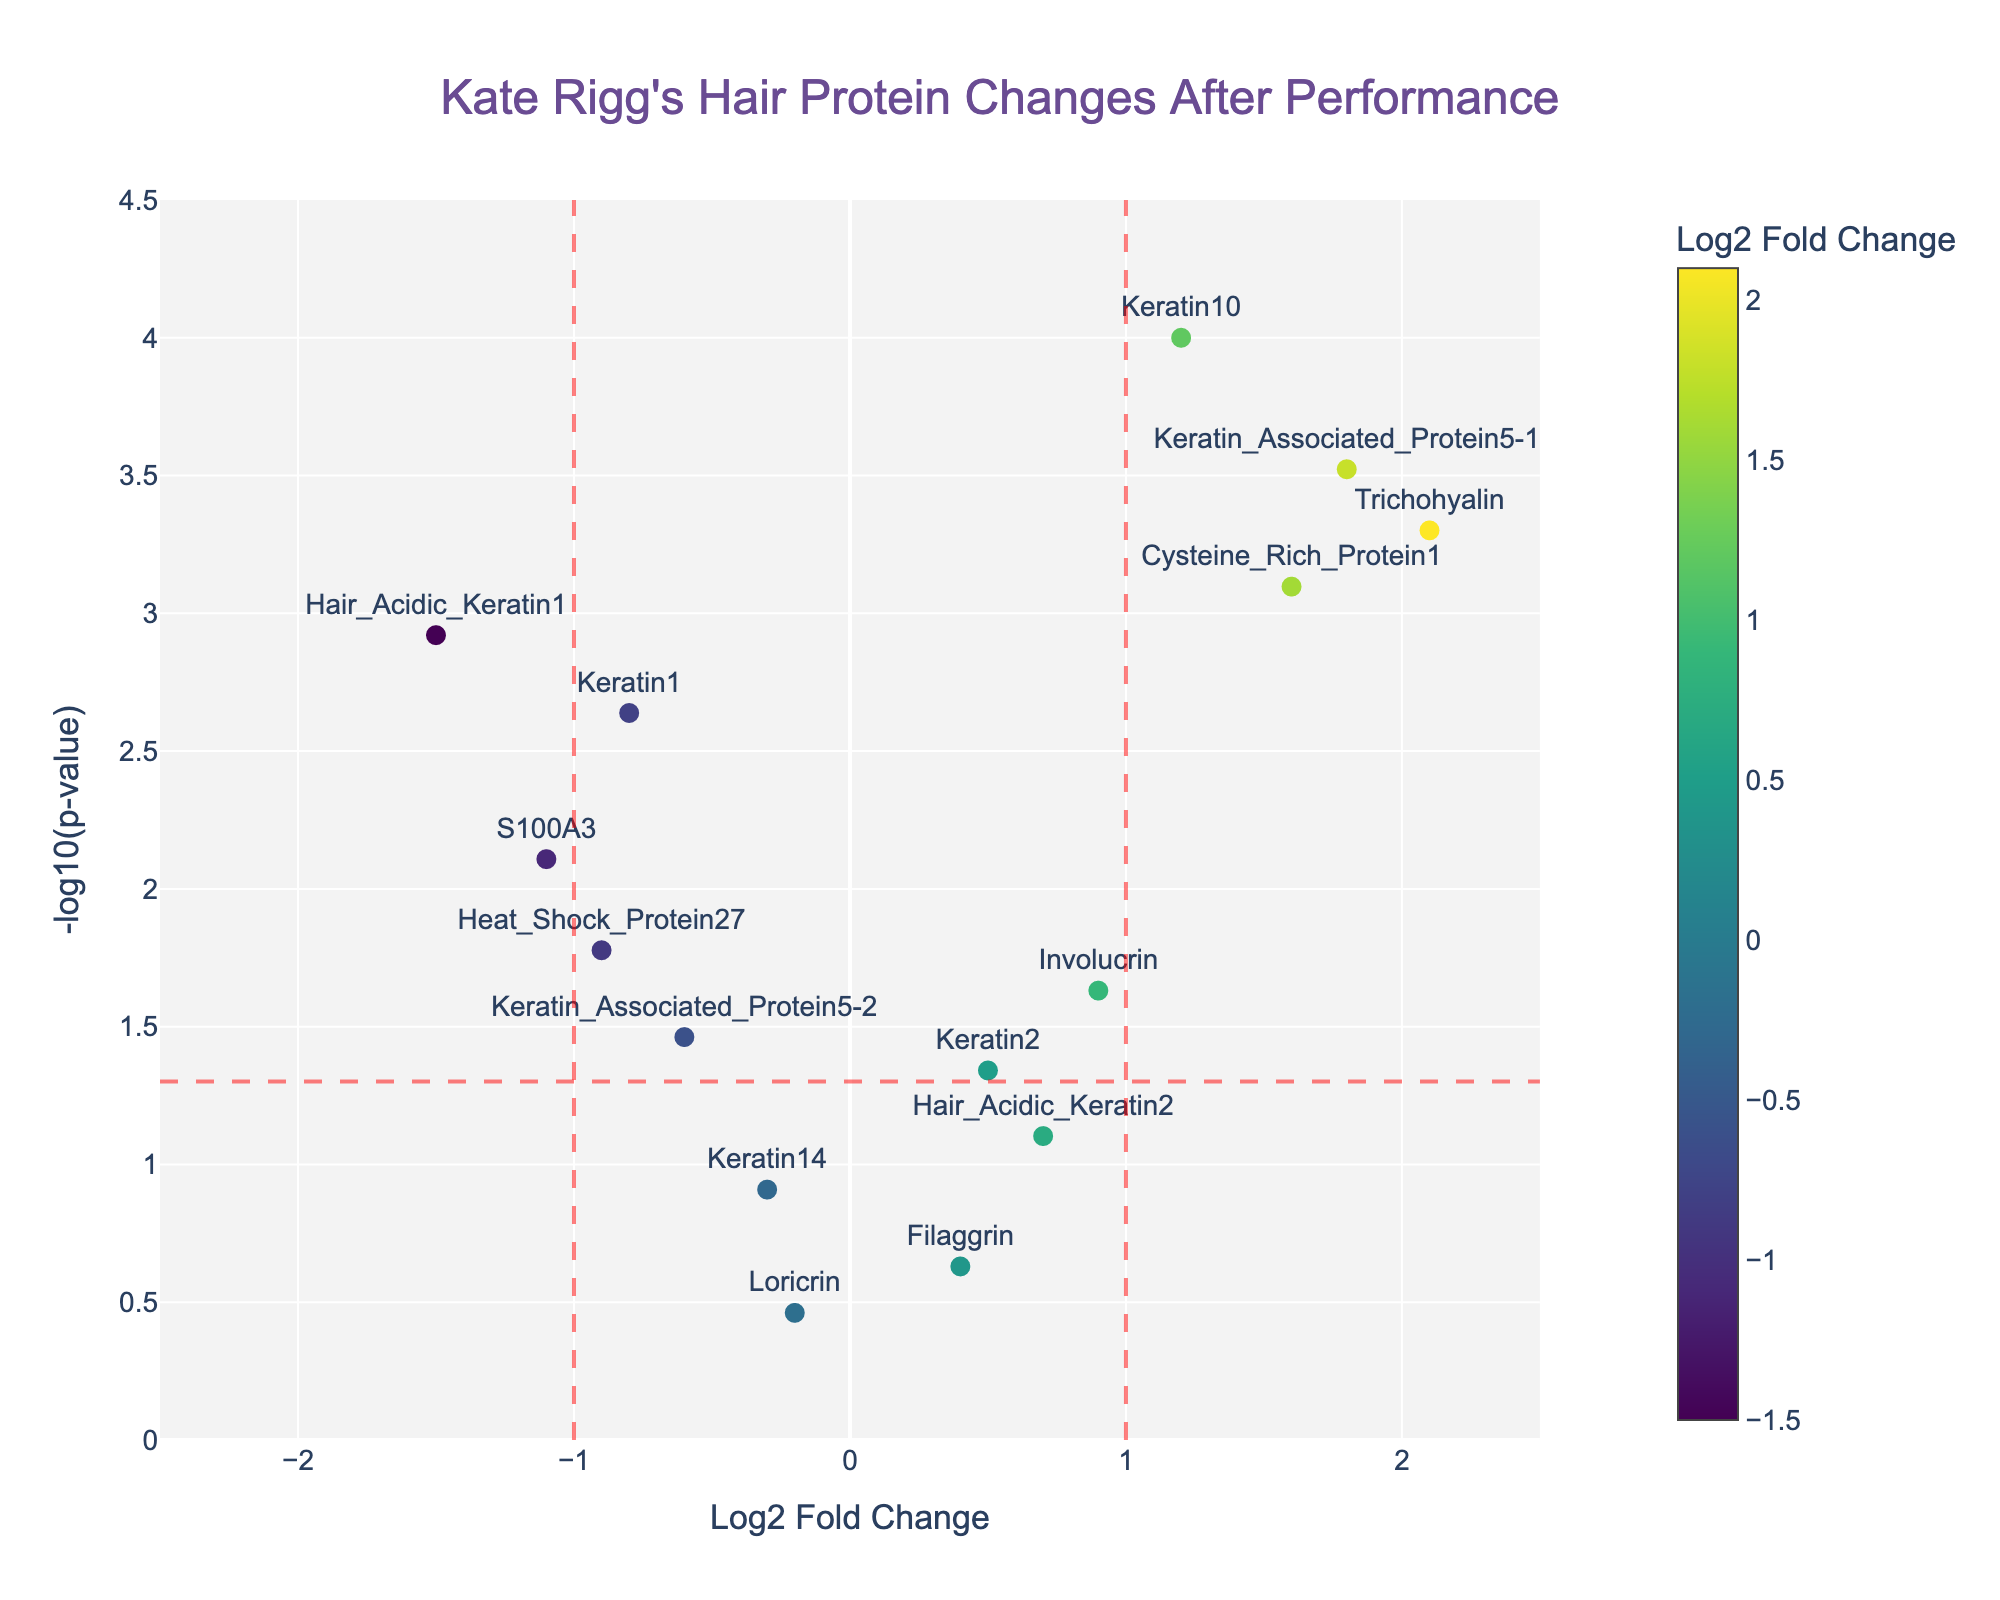What is the title of the plot? The title of the plot is displayed prominently at the top center of the figure and provides an overview of what the plot represents.
Answer: Kate Rigg's Hair Protein Changes After Performance How many proteins have a p-value less than 0.05? Proteins with p-values less than 0.05 are found below the horizontal red dashed line at -log10(p-value) corresponding to 0.05. Count these points.
Answer: 10 Which protein has the highest Log2 Fold Change and what is its p-value? Locate the protein with the highest x-axis value (Log2 Fold Change) and refer to its corresponding p-value from the hover text or the plot.
Answer: Trichohyalin with p-value 0.0005 What are the log2 fold changes for Keratin1 and Keratin14? Find these proteins on the plot and note their x-axis values (Log2 Fold Change).
Answer: -0.8 and -0.3 Which protein shows the most significant change in abundance (in p-value) and indicate its Log2 Fold Change? This is the point with the highest y-axis value (-log10(p-value)). Identify the protein and its corresponding Log2 Fold Change.
Answer: Keratin10 with Log2 Fold Change 1.2 Rank the top three proteins with the highest absolute Log2 Fold Change values. Calculate the absolute values of Log2 Fold Change, then sort and rank them to find the top three.
Answer: Hair_Acidic_Keratin1, Keratin_Associated_Protein5-1, and Trichohyalin Which protein has the smallest Log2 Fold Change but statistically significant (p-value < 0.05)? Identify the smallest Log2 Fold Change (x-axis) among points below the horizontal red dashed line (p-value < 0.05).
Answer: Keratin1 How many proteins have both significant p-values (less than 0.05) and Log2 Fold Change greater than 1? Count the points located in the regions where Log2 Fold Change is greater than 1 and below the red dashed horizontal line.
Answer: 2 Which protein has a Log2 Fold Change closest to 0 and what is its p-value? Find the protein with a Log2 Fold Change value closest to 0 and check its corresponding p-value from the hover text.
Answer: Loricrin with p-value 0.3456 